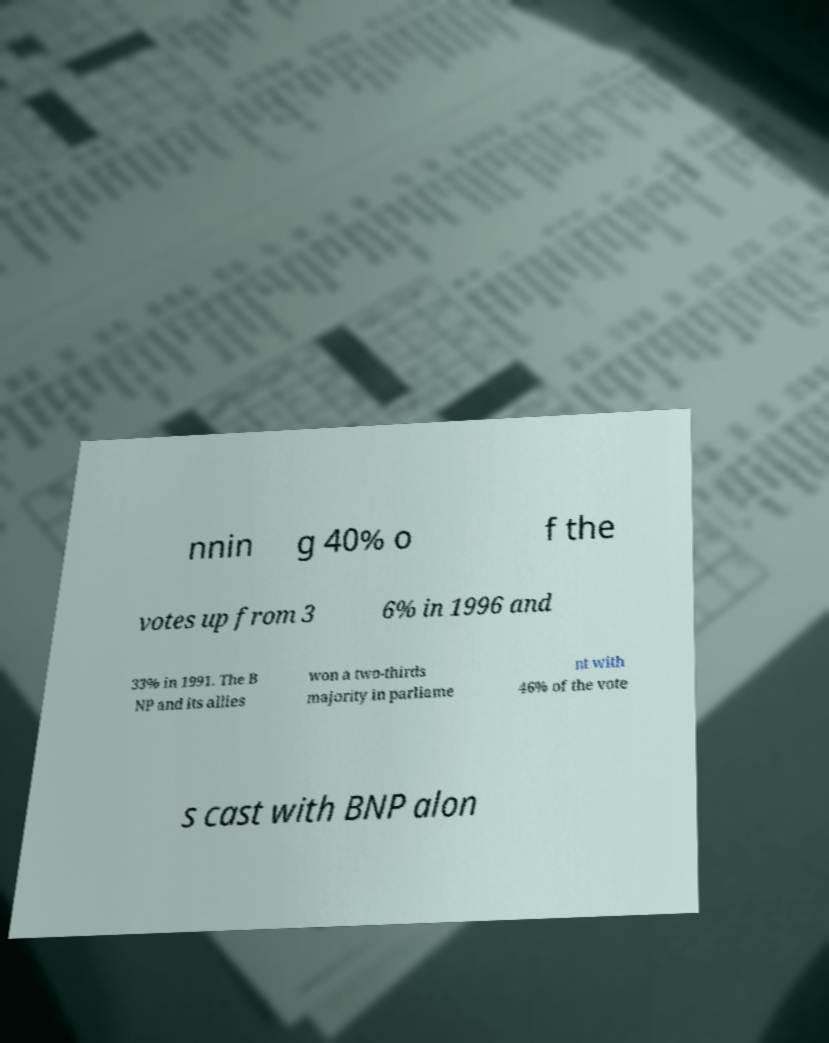Could you assist in decoding the text presented in this image and type it out clearly? nnin g 40% o f the votes up from 3 6% in 1996 and 33% in 1991. The B NP and its allies won a two-thirds majority in parliame nt with 46% of the vote s cast with BNP alon 